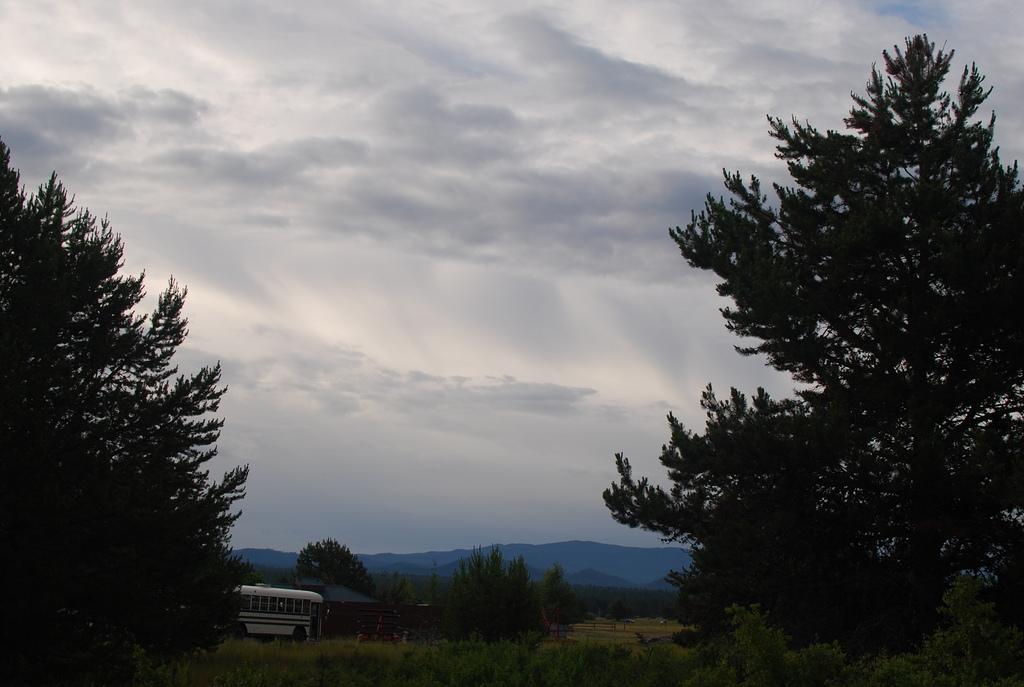How would you summarize this image in a sentence or two? On the the left side and the right there are trees, in the background there is a bus on a road and there are trees, mountains and the sky. 